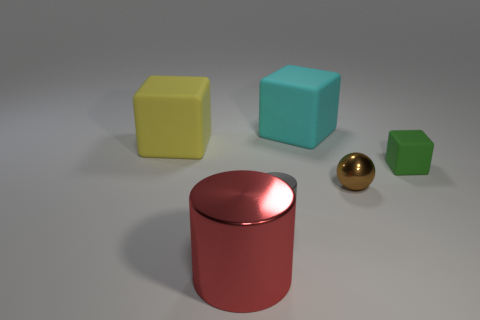Add 3 spheres. How many objects exist? 9 Subtract all balls. How many objects are left? 5 Subtract 1 gray cylinders. How many objects are left? 5 Subtract all small balls. Subtract all big yellow blocks. How many objects are left? 4 Add 5 small spheres. How many small spheres are left? 6 Add 5 small green metallic cylinders. How many small green metallic cylinders exist? 5 